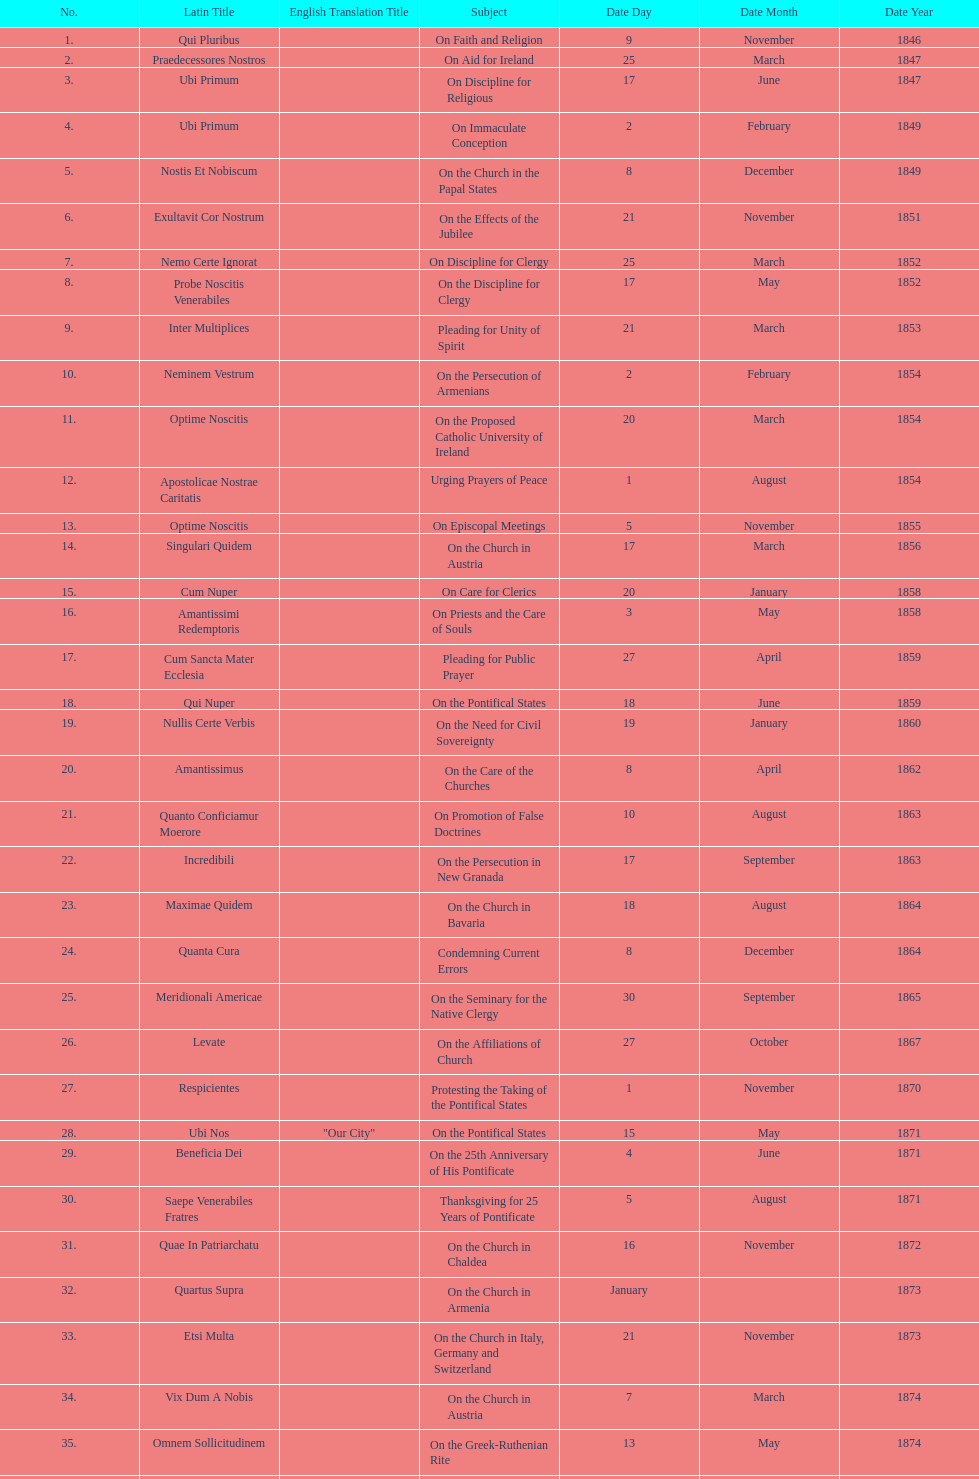Total number of encyclicals on churches . 11. 